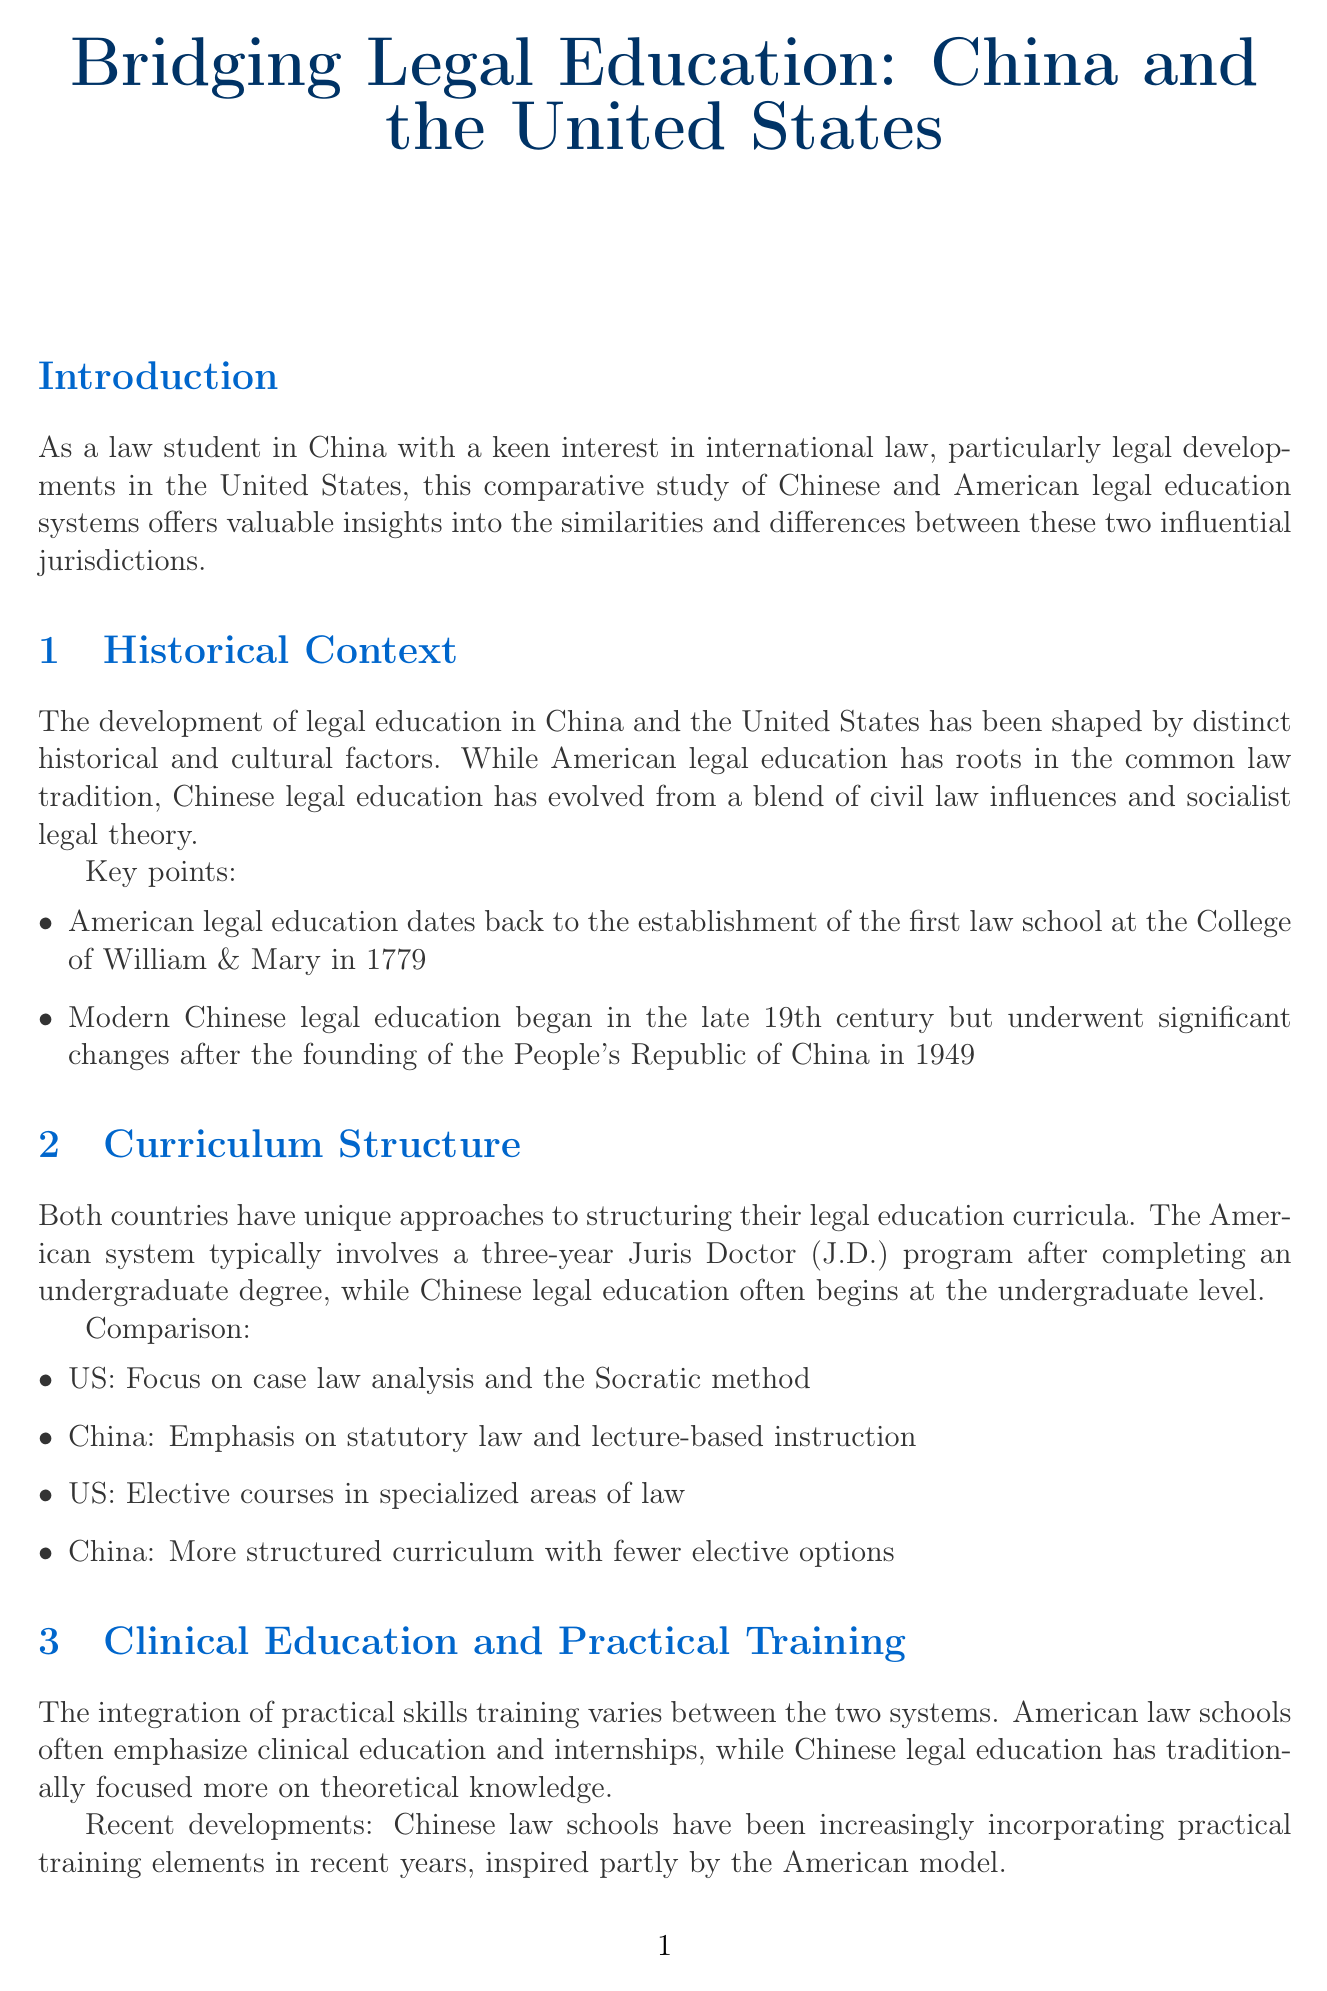what is the title of the newsletter? The title of the newsletter is stated at the beginning of the document as the main heading.
Answer: Bridging Legal Education: China and the United States when was the first law school established in the U.S.? The document mentions the establishment date of the first law school in the context of American legal education history.
Answer: 1779 what is the primary focus of U.S. legal education according to Professor Sarah Johnson? The quote from Professor Sarah Johnson specifically highlights the primary focus of American legal education.
Answer: Critical thinking and legal reasoning skills what type of examination is required to become a licensed attorney in China? The document describes the examination process for becoming a licensed attorney in China, specifying the type of examination used.
Answer: Unified National Judicial Examination which law school does Professor Li Wei belong to? The document provides the affiliation of Professor Li Wei in the context of expert interviews.
Answer: Peking University Law School how many years is the typical Juris Doctor program in the U.S.? The length of the Juris Doctor program is specified in the curriculum structure section of the document.
Answer: Three years what recent development has occurred in Chinese legal education? The document notes a recent change in Chinese legal education related to practical training.
Answer: Incorporating practical training elements what is a future trend mentioned in the document? The document outlines potential future trends for legal education, asking for one example.
Answer: Increasing collaboration between Chinese and American law schools 